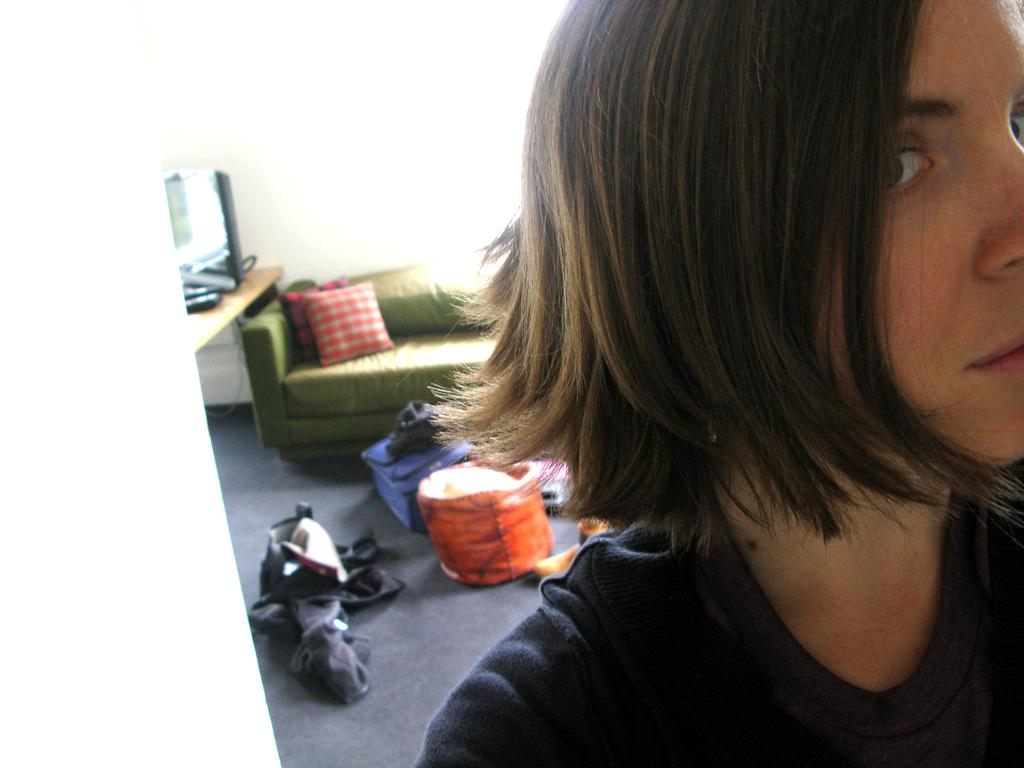What is the main subject in the image? There is a person in the image. What type of furniture is present in the image? There is a sofa in the image. What other objects can be seen in the image? There are some objects in the image. How many friends does the person in the image have? The provided facts do not mention any friends, so it cannot be determined from the image. What type of test is the person in the image taking? There is no indication in the image that the person is taking any test. 